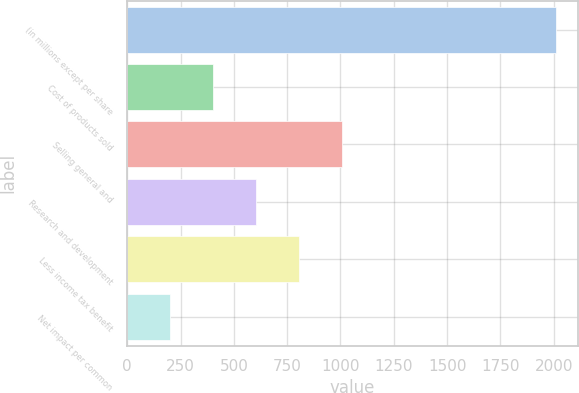Convert chart to OTSL. <chart><loc_0><loc_0><loc_500><loc_500><bar_chart><fcel>(in millions except per share<fcel>Cost of products sold<fcel>Selling general and<fcel>Research and development<fcel>Less income tax benefit<fcel>Net impact per common<nl><fcel>2011<fcel>402.24<fcel>1005.51<fcel>603.33<fcel>804.42<fcel>201.15<nl></chart> 